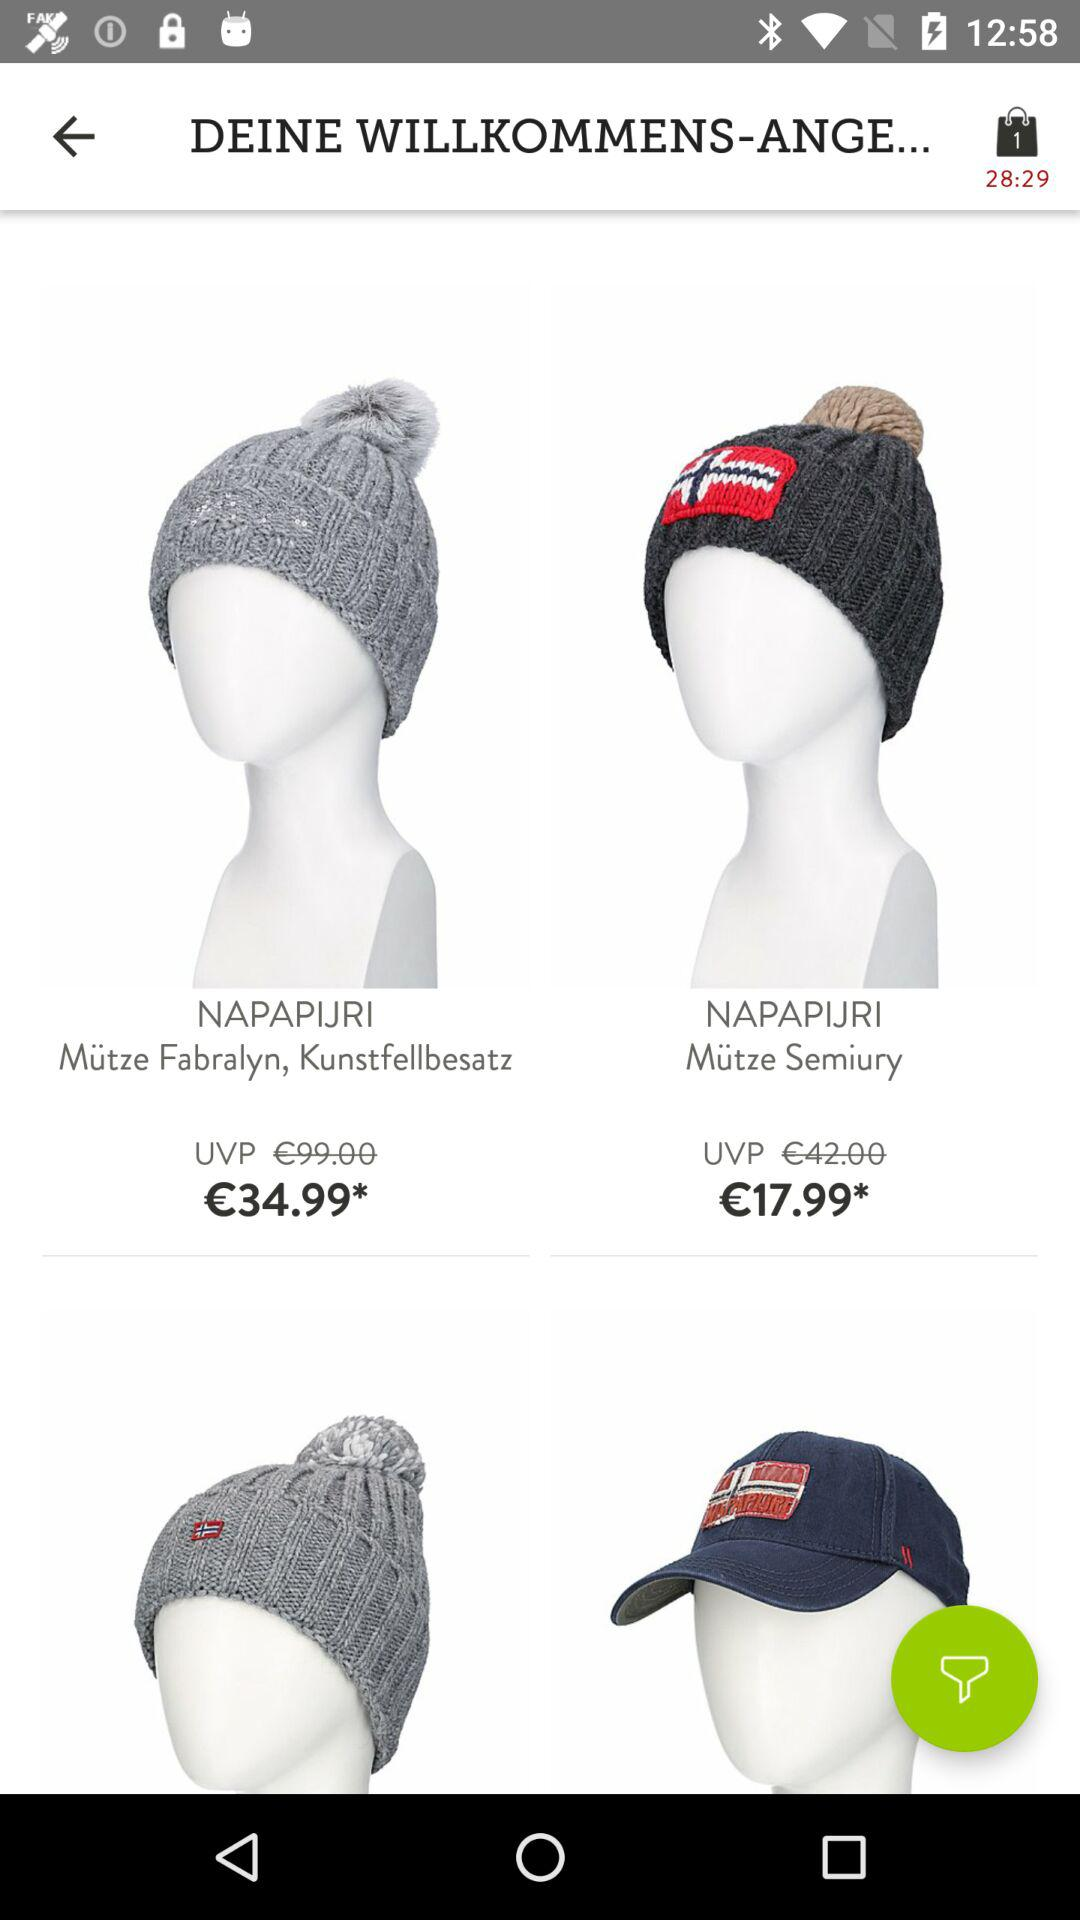What is the number of items added to the bag? The number of items added to the bag is 1. 